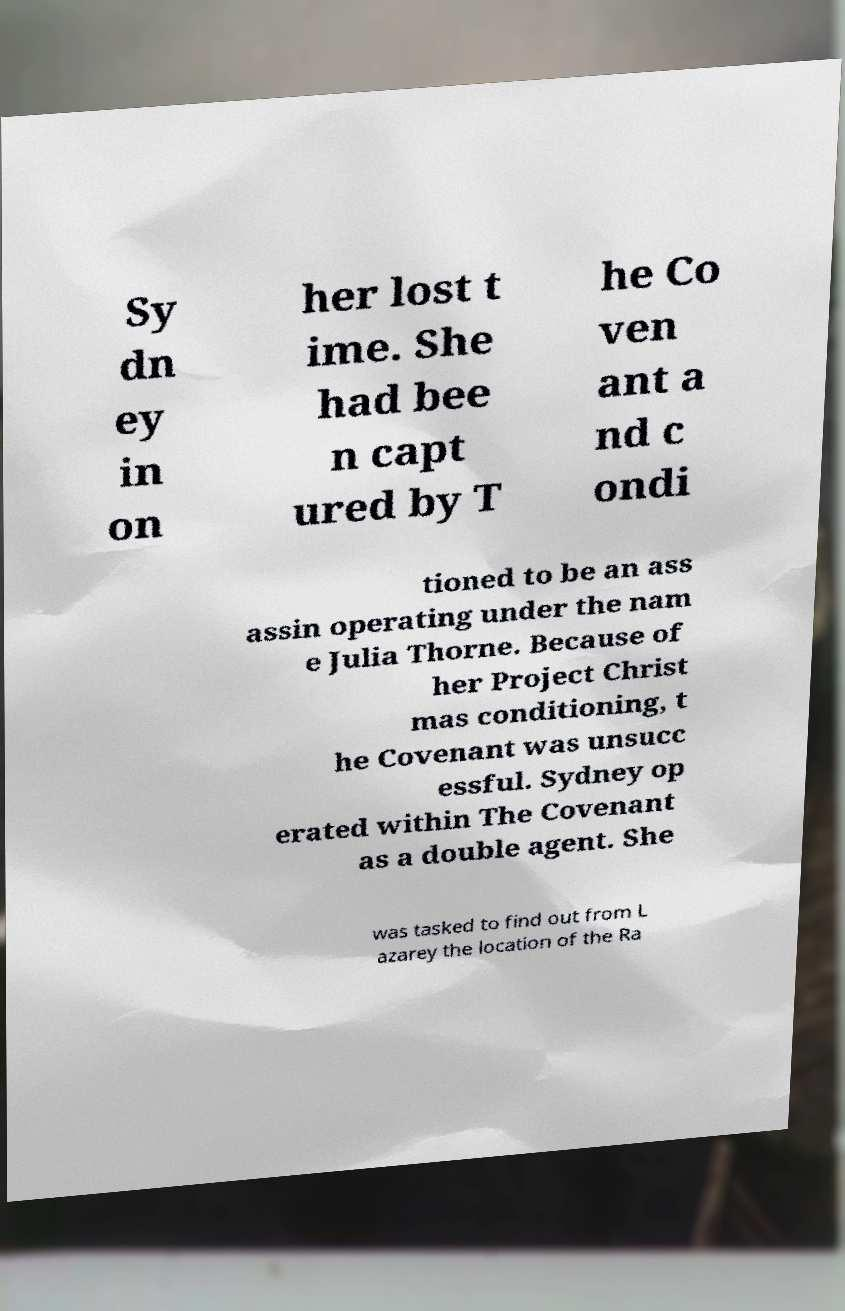Could you assist in decoding the text presented in this image and type it out clearly? Sy dn ey in on her lost t ime. She had bee n capt ured by T he Co ven ant a nd c ondi tioned to be an ass assin operating under the nam e Julia Thorne. Because of her Project Christ mas conditioning, t he Covenant was unsucc essful. Sydney op erated within The Covenant as a double agent. She was tasked to find out from L azarey the location of the Ra 